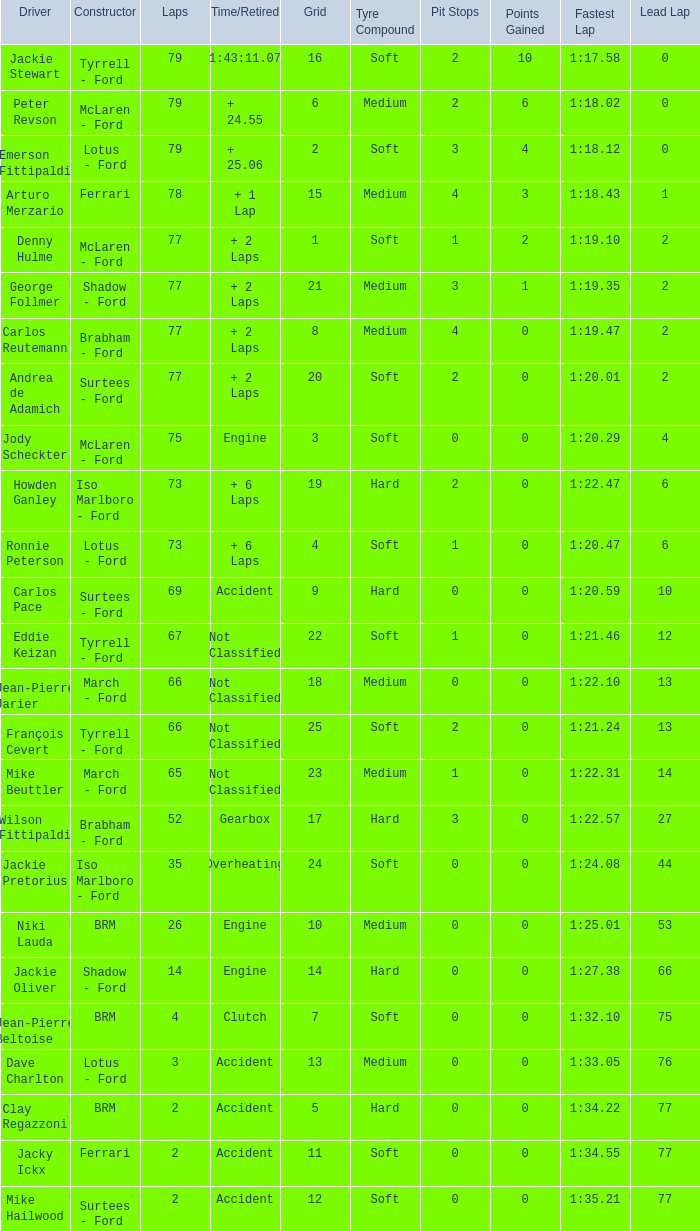How much time is required for less than 35 laps and less than 10 grids? Clutch, Accident. Parse the table in full. {'header': ['Driver', 'Constructor', 'Laps', 'Time/Retired', 'Grid', 'Tyre Compound', 'Pit Stops', 'Points Gained', 'Fastest Lap', 'Lead Lap'], 'rows': [['Jackie Stewart', 'Tyrrell - Ford', '79', '1:43:11.07', '16', 'Soft', '2', '10', '1:17.58', '0'], ['Peter Revson', 'McLaren - Ford', '79', '+ 24.55', '6', 'Medium', '2', '6', '1:18.02', '0'], ['Emerson Fittipaldi', 'Lotus - Ford', '79', '+ 25.06', '2', 'Soft', '3', '4', '1:18.12', '0'], ['Arturo Merzario', 'Ferrari', '78', '+ 1 Lap', '15', 'Medium', '4', '3', '1:18.43', '1'], ['Denny Hulme', 'McLaren - Ford', '77', '+ 2 Laps', '1', 'Soft', '1', '2', '1:19.10', '2'], ['George Follmer', 'Shadow - Ford', '77', '+ 2 Laps', '21', 'Medium', '3', '1', '1:19.35', '2'], ['Carlos Reutemann', 'Brabham - Ford', '77', '+ 2 Laps', '8', 'Medium', '4', '0', '1:19.47', '2'], ['Andrea de Adamich', 'Surtees - Ford', '77', '+ 2 Laps', '20', 'Soft', '2', '0', '1:20.01', '2'], ['Jody Scheckter', 'McLaren - Ford', '75', 'Engine', '3', 'Soft', '0', '0', '1:20.29', '4'], ['Howden Ganley', 'Iso Marlboro - Ford', '73', '+ 6 Laps', '19', 'Hard', '2', '0', '1:22.47', '6'], ['Ronnie Peterson', 'Lotus - Ford', '73', '+ 6 Laps', '4', 'Soft', '1', '0', '1:20.47', '6'], ['Carlos Pace', 'Surtees - Ford', '69', 'Accident', '9', 'Hard', '0', '0', '1:20.59', '10'], ['Eddie Keizan', 'Tyrrell - Ford', '67', 'Not Classified', '22', 'Soft', '1', '0', '1:21.46', '12'], ['Jean-Pierre Jarier', 'March - Ford', '66', 'Not Classified', '18', 'Medium', '0', '0', '1:22.10', '13'], ['François Cevert', 'Tyrrell - Ford', '66', 'Not Classified', '25', 'Soft', '2', '0', '1:21.24', '13'], ['Mike Beuttler', 'March - Ford', '65', 'Not Classified', '23', 'Medium', '1', '0', '1:22.31', '14'], ['Wilson Fittipaldi', 'Brabham - Ford', '52', 'Gearbox', '17', 'Hard', '3', '0', '1:22.57', '27'], ['Jackie Pretorius', 'Iso Marlboro - Ford', '35', 'Overheating', '24', 'Soft', '0', '0', '1:24.08', '44'], ['Niki Lauda', 'BRM', '26', 'Engine', '10', 'Medium', '0', '0', '1:25.01', '53'], ['Jackie Oliver', 'Shadow - Ford', '14', 'Engine', '14', 'Hard', '0', '0', '1:27.38', '66'], ['Jean-Pierre Beltoise', 'BRM', '4', 'Clutch', '7', 'Soft', '0', '0', '1:32.10', '75'], ['Dave Charlton', 'Lotus - Ford', '3', 'Accident', '13', 'Medium', '0', '0', '1:33.05', '76'], ['Clay Regazzoni', 'BRM', '2', 'Accident', '5', 'Hard', '0', '0', '1:34.22', '77'], ['Jacky Ickx', 'Ferrari', '2', 'Accident', '11', 'Soft', '0', '0', '1:34.55', '77'], ['Mike Hailwood', 'Surtees - Ford', '2', 'Accident', '12', 'Soft', '0', '0', '1:35.21', '77']]} 